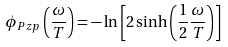<formula> <loc_0><loc_0><loc_500><loc_500>\phi _ { P z p } \left ( \frac { \omega } { T } \right ) = - \ln \left [ 2 \sinh \left ( \frac { 1 } { 2 } \frac { \omega } { T } \right ) \right ]</formula> 